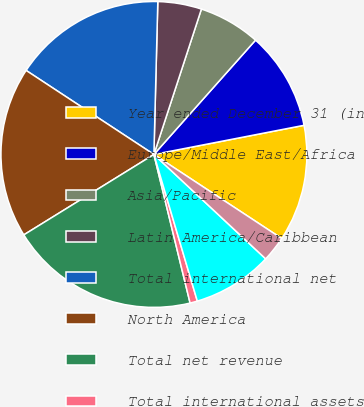Convert chart to OTSL. <chart><loc_0><loc_0><loc_500><loc_500><pie_chart><fcel>Year ended December 31 (in<fcel>Europe/Middle East/Africa<fcel>Asia/Pacific<fcel>Latin America/Caribbean<fcel>Total international net<fcel>North America<fcel>Total net revenue<fcel>Total international assets<fcel>Total assets under management<fcel>Total international client<nl><fcel>12.31%<fcel>10.38%<fcel>6.54%<fcel>4.62%<fcel>16.15%<fcel>18.07%<fcel>19.99%<fcel>0.78%<fcel>8.46%<fcel>2.7%<nl></chart> 